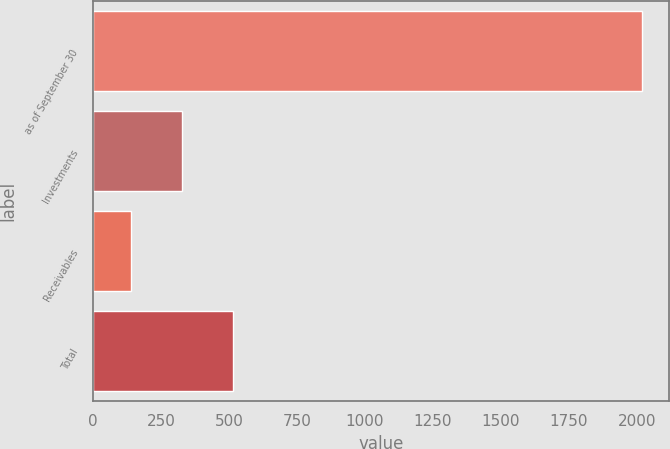Convert chart to OTSL. <chart><loc_0><loc_0><loc_500><loc_500><bar_chart><fcel>as of September 30<fcel>Investments<fcel>Receivables<fcel>Total<nl><fcel>2018<fcel>327.89<fcel>140.1<fcel>515.68<nl></chart> 